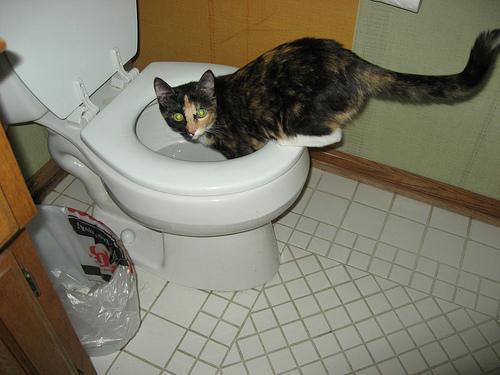How many cats in the photo?
Give a very brief answer. 1. 